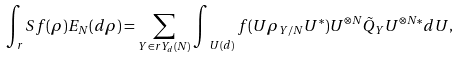<formula> <loc_0><loc_0><loc_500><loc_500>\int _ { r } { S } f ( \rho ) E _ { N } ( d \rho ) = \sum _ { Y \in r { Y } _ { d } ( N ) } \int _ { \ U ( d ) } f ( U \rho _ { Y / N } U ^ { * } ) U ^ { \otimes N } \tilde { Q } _ { Y } U ^ { \otimes N * } d U ,</formula> 